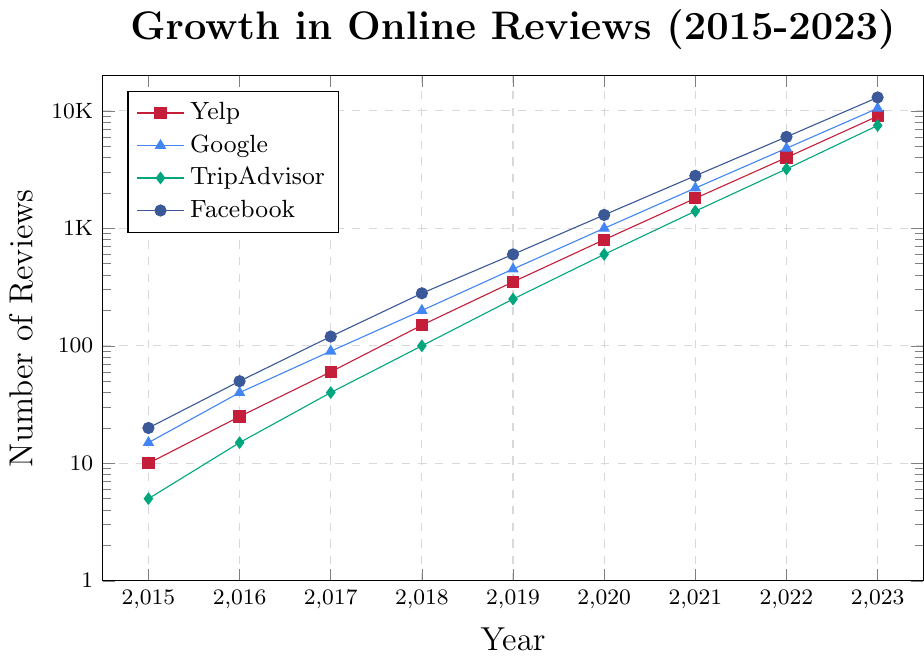Which platform had the highest number of reviews in 2023? The figure shows the trajectory of reviews for each platform over the years. By examining the highest point in 2023 for each platform, we can see that Facebook (13000 reviews) is the highest.
Answer: Facebook What was the growth in Yelp reviews from 2019 to 2023? To find the growth, subtract the number of Yelp reviews in 2019 (350) from the number in 2023 (9000). 9000 - 350 = 8650.
Answer: 8650 Among Yelp, Google, TripAdvisor, and Facebook, which platform had the smallest increase in reviews from 2015 to 2020? Calculate the difference for each platform from 2015 to 2020: Yelp (800 - 10 = 790), Google (1000 - 15 = 985), TripAdvisor (600 - 5 = 595), Facebook (1300 - 20 = 1280). The smallest increase is for TripAdvisor (595).
Answer: TripAdvisor Which year saw a larger increase in Facebook reviews compared to the previous year: 2019 or 2020? Calculate the increase for each year compared to the previous: 2019 (600 - 280 = 320), 2020 (1300 - 600 = 700). Compare these values, and 2020 has the larger increase.
Answer: 2020 How many total reviews were there in 2021 across all platforms? Sum the reviews for Yelp (1800), Google (2200), TripAdvisor (1400), and Facebook (2800) in 2021. 1800 + 2200 + 1400 + 2800 = 8200.
Answer: 8200 Which platform had the steepest growth rate visually from 2015 to 2023? Visually, the platform with the steepest slope (line) indicates the highest growth rate. Observing the plot, Facebook's line appears the steepest.
Answer: Facebook In which year did Google reviews first exceed 1000? By following Google’s review trajectory, Google reviews first exceed 1000 in the year 2020.
Answer: 2020 By which year did Yelp reviews surpass Google reviews? Analyze the point where Yelp exceeds Google in the number of reviews. This crossover occurs between 2019 and 2020. So, it happened by the year 2020.
Answer: 2020 